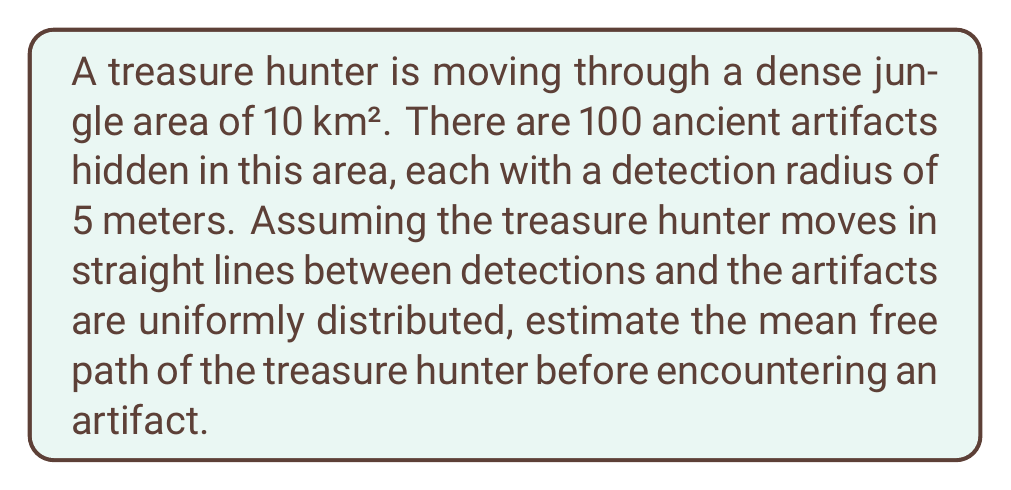Solve this math problem. To solve this problem, we'll use concepts from statistical mechanics, specifically the mean free path formula:

$$\lambda = \frac{1}{n\sigma}$$

Where:
$\lambda$ = mean free path
$n$ = number density of targets (artifacts)
$\sigma$ = cross-sectional area of interaction

Step 1: Calculate the number density (n)
$$n = \frac{\text{Number of artifacts}}{\text{Total area}} = \frac{100}{10 \text{ km}^2} = 10 \text{ artifacts/km}^2$$

Step 2: Calculate the cross-sectional area ($\sigma$)
The detection radius is 5 meters, so the cross-sectional area is:
$$\sigma = \pi r^2 = \pi (5 \text{ m})^2 = 78.54 \text{ m}^2 = 7.854 \times 10^{-5} \text{ km}^2$$

Step 3: Calculate the mean free path
$$\lambda = \frac{1}{n\sigma} = \frac{1}{(10 \text{ artifacts/km}^2)(7.854 \times 10^{-5} \text{ km}^2)} = 1.273 \text{ km}$$

Therefore, the estimated mean free path of the treasure hunter before encountering an artifact is approximately 1.273 km.
Answer: 1.273 km 